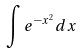<formula> <loc_0><loc_0><loc_500><loc_500>\int e ^ { - x ^ { 2 } } d x</formula> 